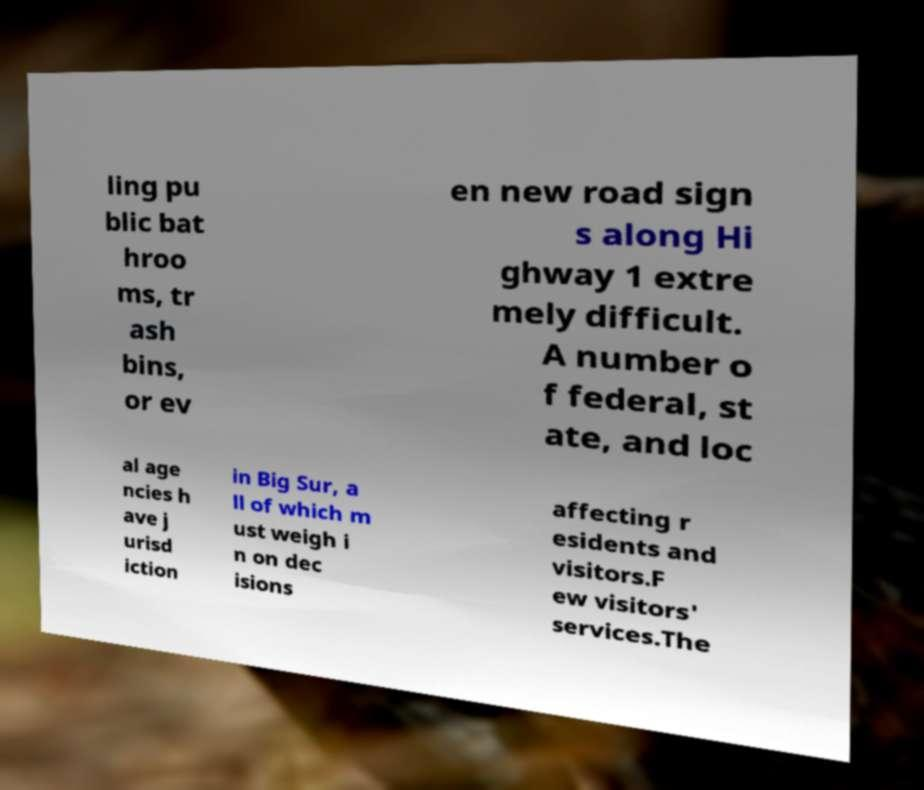Please read and relay the text visible in this image. What does it say? ling pu blic bat hroo ms, tr ash bins, or ev en new road sign s along Hi ghway 1 extre mely difficult. A number o f federal, st ate, and loc al age ncies h ave j urisd iction in Big Sur, a ll of which m ust weigh i n on dec isions affecting r esidents and visitors.F ew visitors' services.The 